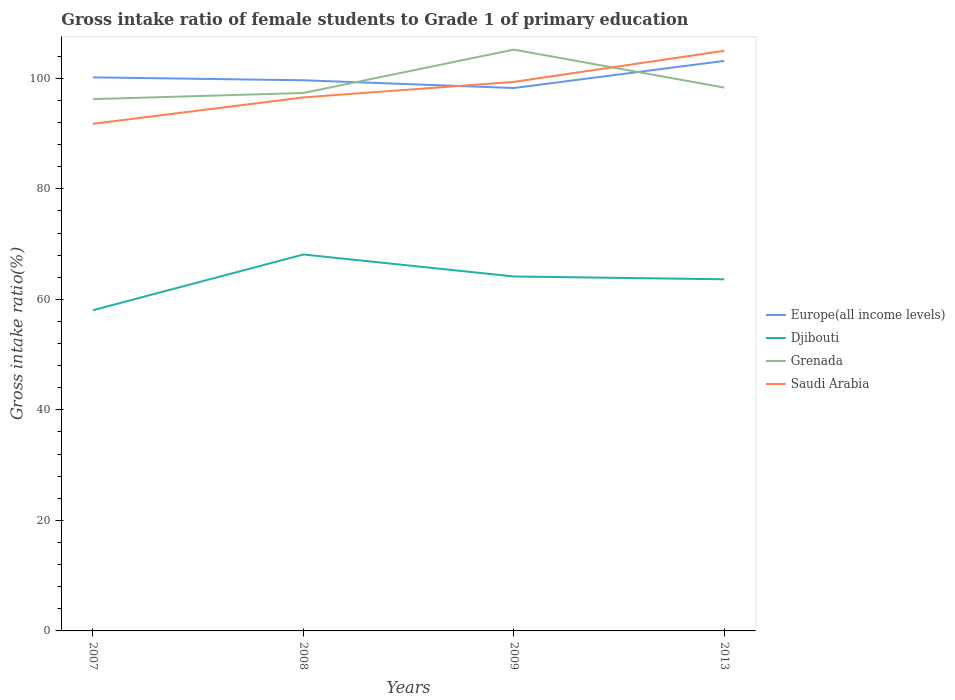How many different coloured lines are there?
Offer a very short reply. 4. Across all years, what is the maximum gross intake ratio in Saudi Arabia?
Keep it short and to the point. 91.78. In which year was the gross intake ratio in Saudi Arabia maximum?
Offer a very short reply. 2007. What is the total gross intake ratio in Grenada in the graph?
Your response must be concise. -1.11. What is the difference between the highest and the second highest gross intake ratio in Djibouti?
Your answer should be compact. 10.08. What is the difference between the highest and the lowest gross intake ratio in Europe(all income levels)?
Keep it short and to the point. 1. How many lines are there?
Ensure brevity in your answer.  4. How many years are there in the graph?
Ensure brevity in your answer.  4. What is the difference between two consecutive major ticks on the Y-axis?
Give a very brief answer. 20. Are the values on the major ticks of Y-axis written in scientific E-notation?
Offer a terse response. No. Does the graph contain any zero values?
Offer a terse response. No. How many legend labels are there?
Keep it short and to the point. 4. How are the legend labels stacked?
Make the answer very short. Vertical. What is the title of the graph?
Keep it short and to the point. Gross intake ratio of female students to Grade 1 of primary education. What is the label or title of the Y-axis?
Ensure brevity in your answer.  Gross intake ratio(%). What is the Gross intake ratio(%) of Europe(all income levels) in 2007?
Your response must be concise. 100.18. What is the Gross intake ratio(%) in Djibouti in 2007?
Provide a succinct answer. 58.04. What is the Gross intake ratio(%) of Grenada in 2007?
Offer a very short reply. 96.24. What is the Gross intake ratio(%) of Saudi Arabia in 2007?
Your answer should be very brief. 91.78. What is the Gross intake ratio(%) of Europe(all income levels) in 2008?
Your answer should be very brief. 99.66. What is the Gross intake ratio(%) in Djibouti in 2008?
Provide a succinct answer. 68.12. What is the Gross intake ratio(%) in Grenada in 2008?
Your answer should be compact. 97.35. What is the Gross intake ratio(%) in Saudi Arabia in 2008?
Offer a terse response. 96.55. What is the Gross intake ratio(%) of Europe(all income levels) in 2009?
Offer a terse response. 98.25. What is the Gross intake ratio(%) in Djibouti in 2009?
Make the answer very short. 64.15. What is the Gross intake ratio(%) of Grenada in 2009?
Provide a short and direct response. 105.2. What is the Gross intake ratio(%) in Saudi Arabia in 2009?
Your answer should be compact. 99.36. What is the Gross intake ratio(%) in Europe(all income levels) in 2013?
Offer a terse response. 103.16. What is the Gross intake ratio(%) of Djibouti in 2013?
Offer a very short reply. 63.64. What is the Gross intake ratio(%) in Grenada in 2013?
Provide a short and direct response. 98.33. What is the Gross intake ratio(%) of Saudi Arabia in 2013?
Give a very brief answer. 104.99. Across all years, what is the maximum Gross intake ratio(%) in Europe(all income levels)?
Keep it short and to the point. 103.16. Across all years, what is the maximum Gross intake ratio(%) in Djibouti?
Your answer should be compact. 68.12. Across all years, what is the maximum Gross intake ratio(%) in Grenada?
Your response must be concise. 105.2. Across all years, what is the maximum Gross intake ratio(%) of Saudi Arabia?
Keep it short and to the point. 104.99. Across all years, what is the minimum Gross intake ratio(%) of Europe(all income levels)?
Offer a terse response. 98.25. Across all years, what is the minimum Gross intake ratio(%) of Djibouti?
Provide a succinct answer. 58.04. Across all years, what is the minimum Gross intake ratio(%) of Grenada?
Give a very brief answer. 96.24. Across all years, what is the minimum Gross intake ratio(%) in Saudi Arabia?
Provide a short and direct response. 91.78. What is the total Gross intake ratio(%) in Europe(all income levels) in the graph?
Your answer should be very brief. 401.25. What is the total Gross intake ratio(%) of Djibouti in the graph?
Your answer should be compact. 253.95. What is the total Gross intake ratio(%) of Grenada in the graph?
Provide a short and direct response. 397.13. What is the total Gross intake ratio(%) in Saudi Arabia in the graph?
Ensure brevity in your answer.  392.68. What is the difference between the Gross intake ratio(%) in Europe(all income levels) in 2007 and that in 2008?
Keep it short and to the point. 0.52. What is the difference between the Gross intake ratio(%) in Djibouti in 2007 and that in 2008?
Make the answer very short. -10.08. What is the difference between the Gross intake ratio(%) of Grenada in 2007 and that in 2008?
Offer a terse response. -1.11. What is the difference between the Gross intake ratio(%) of Saudi Arabia in 2007 and that in 2008?
Ensure brevity in your answer.  -4.77. What is the difference between the Gross intake ratio(%) of Europe(all income levels) in 2007 and that in 2009?
Make the answer very short. 1.93. What is the difference between the Gross intake ratio(%) of Djibouti in 2007 and that in 2009?
Offer a terse response. -6.1. What is the difference between the Gross intake ratio(%) of Grenada in 2007 and that in 2009?
Your response must be concise. -8.96. What is the difference between the Gross intake ratio(%) of Saudi Arabia in 2007 and that in 2009?
Offer a terse response. -7.58. What is the difference between the Gross intake ratio(%) of Europe(all income levels) in 2007 and that in 2013?
Make the answer very short. -2.98. What is the difference between the Gross intake ratio(%) of Djibouti in 2007 and that in 2013?
Offer a very short reply. -5.59. What is the difference between the Gross intake ratio(%) of Grenada in 2007 and that in 2013?
Your answer should be very brief. -2.09. What is the difference between the Gross intake ratio(%) of Saudi Arabia in 2007 and that in 2013?
Your answer should be compact. -13.21. What is the difference between the Gross intake ratio(%) of Europe(all income levels) in 2008 and that in 2009?
Ensure brevity in your answer.  1.4. What is the difference between the Gross intake ratio(%) of Djibouti in 2008 and that in 2009?
Provide a succinct answer. 3.98. What is the difference between the Gross intake ratio(%) of Grenada in 2008 and that in 2009?
Keep it short and to the point. -7.85. What is the difference between the Gross intake ratio(%) in Saudi Arabia in 2008 and that in 2009?
Your answer should be very brief. -2.81. What is the difference between the Gross intake ratio(%) in Europe(all income levels) in 2008 and that in 2013?
Give a very brief answer. -3.5. What is the difference between the Gross intake ratio(%) in Djibouti in 2008 and that in 2013?
Provide a succinct answer. 4.49. What is the difference between the Gross intake ratio(%) in Grenada in 2008 and that in 2013?
Provide a short and direct response. -0.98. What is the difference between the Gross intake ratio(%) of Saudi Arabia in 2008 and that in 2013?
Give a very brief answer. -8.44. What is the difference between the Gross intake ratio(%) in Europe(all income levels) in 2009 and that in 2013?
Keep it short and to the point. -4.9. What is the difference between the Gross intake ratio(%) in Djibouti in 2009 and that in 2013?
Provide a succinct answer. 0.51. What is the difference between the Gross intake ratio(%) in Grenada in 2009 and that in 2013?
Your answer should be compact. 6.87. What is the difference between the Gross intake ratio(%) in Saudi Arabia in 2009 and that in 2013?
Give a very brief answer. -5.62. What is the difference between the Gross intake ratio(%) in Europe(all income levels) in 2007 and the Gross intake ratio(%) in Djibouti in 2008?
Provide a short and direct response. 32.06. What is the difference between the Gross intake ratio(%) of Europe(all income levels) in 2007 and the Gross intake ratio(%) of Grenada in 2008?
Your answer should be compact. 2.83. What is the difference between the Gross intake ratio(%) of Europe(all income levels) in 2007 and the Gross intake ratio(%) of Saudi Arabia in 2008?
Make the answer very short. 3.63. What is the difference between the Gross intake ratio(%) in Djibouti in 2007 and the Gross intake ratio(%) in Grenada in 2008?
Your answer should be compact. -39.31. What is the difference between the Gross intake ratio(%) of Djibouti in 2007 and the Gross intake ratio(%) of Saudi Arabia in 2008?
Your response must be concise. -38.51. What is the difference between the Gross intake ratio(%) of Grenada in 2007 and the Gross intake ratio(%) of Saudi Arabia in 2008?
Offer a very short reply. -0.31. What is the difference between the Gross intake ratio(%) in Europe(all income levels) in 2007 and the Gross intake ratio(%) in Djibouti in 2009?
Keep it short and to the point. 36.03. What is the difference between the Gross intake ratio(%) in Europe(all income levels) in 2007 and the Gross intake ratio(%) in Grenada in 2009?
Ensure brevity in your answer.  -5.02. What is the difference between the Gross intake ratio(%) of Europe(all income levels) in 2007 and the Gross intake ratio(%) of Saudi Arabia in 2009?
Keep it short and to the point. 0.82. What is the difference between the Gross intake ratio(%) in Djibouti in 2007 and the Gross intake ratio(%) in Grenada in 2009?
Keep it short and to the point. -47.16. What is the difference between the Gross intake ratio(%) of Djibouti in 2007 and the Gross intake ratio(%) of Saudi Arabia in 2009?
Provide a short and direct response. -41.32. What is the difference between the Gross intake ratio(%) in Grenada in 2007 and the Gross intake ratio(%) in Saudi Arabia in 2009?
Your response must be concise. -3.12. What is the difference between the Gross intake ratio(%) in Europe(all income levels) in 2007 and the Gross intake ratio(%) in Djibouti in 2013?
Provide a succinct answer. 36.54. What is the difference between the Gross intake ratio(%) of Europe(all income levels) in 2007 and the Gross intake ratio(%) of Grenada in 2013?
Your response must be concise. 1.85. What is the difference between the Gross intake ratio(%) of Europe(all income levels) in 2007 and the Gross intake ratio(%) of Saudi Arabia in 2013?
Your answer should be very brief. -4.81. What is the difference between the Gross intake ratio(%) in Djibouti in 2007 and the Gross intake ratio(%) in Grenada in 2013?
Your answer should be compact. -40.29. What is the difference between the Gross intake ratio(%) of Djibouti in 2007 and the Gross intake ratio(%) of Saudi Arabia in 2013?
Offer a terse response. -46.94. What is the difference between the Gross intake ratio(%) in Grenada in 2007 and the Gross intake ratio(%) in Saudi Arabia in 2013?
Your response must be concise. -8.75. What is the difference between the Gross intake ratio(%) of Europe(all income levels) in 2008 and the Gross intake ratio(%) of Djibouti in 2009?
Your response must be concise. 35.51. What is the difference between the Gross intake ratio(%) of Europe(all income levels) in 2008 and the Gross intake ratio(%) of Grenada in 2009?
Offer a terse response. -5.55. What is the difference between the Gross intake ratio(%) of Europe(all income levels) in 2008 and the Gross intake ratio(%) of Saudi Arabia in 2009?
Make the answer very short. 0.29. What is the difference between the Gross intake ratio(%) in Djibouti in 2008 and the Gross intake ratio(%) in Grenada in 2009?
Give a very brief answer. -37.08. What is the difference between the Gross intake ratio(%) in Djibouti in 2008 and the Gross intake ratio(%) in Saudi Arabia in 2009?
Your response must be concise. -31.24. What is the difference between the Gross intake ratio(%) of Grenada in 2008 and the Gross intake ratio(%) of Saudi Arabia in 2009?
Offer a very short reply. -2.01. What is the difference between the Gross intake ratio(%) of Europe(all income levels) in 2008 and the Gross intake ratio(%) of Djibouti in 2013?
Give a very brief answer. 36.02. What is the difference between the Gross intake ratio(%) of Europe(all income levels) in 2008 and the Gross intake ratio(%) of Grenada in 2013?
Your response must be concise. 1.32. What is the difference between the Gross intake ratio(%) of Europe(all income levels) in 2008 and the Gross intake ratio(%) of Saudi Arabia in 2013?
Keep it short and to the point. -5.33. What is the difference between the Gross intake ratio(%) in Djibouti in 2008 and the Gross intake ratio(%) in Grenada in 2013?
Provide a short and direct response. -30.21. What is the difference between the Gross intake ratio(%) of Djibouti in 2008 and the Gross intake ratio(%) of Saudi Arabia in 2013?
Ensure brevity in your answer.  -36.86. What is the difference between the Gross intake ratio(%) of Grenada in 2008 and the Gross intake ratio(%) of Saudi Arabia in 2013?
Your answer should be very brief. -7.63. What is the difference between the Gross intake ratio(%) in Europe(all income levels) in 2009 and the Gross intake ratio(%) in Djibouti in 2013?
Give a very brief answer. 34.62. What is the difference between the Gross intake ratio(%) of Europe(all income levels) in 2009 and the Gross intake ratio(%) of Grenada in 2013?
Ensure brevity in your answer.  -0.08. What is the difference between the Gross intake ratio(%) in Europe(all income levels) in 2009 and the Gross intake ratio(%) in Saudi Arabia in 2013?
Ensure brevity in your answer.  -6.73. What is the difference between the Gross intake ratio(%) of Djibouti in 2009 and the Gross intake ratio(%) of Grenada in 2013?
Provide a short and direct response. -34.18. What is the difference between the Gross intake ratio(%) of Djibouti in 2009 and the Gross intake ratio(%) of Saudi Arabia in 2013?
Your response must be concise. -40.84. What is the difference between the Gross intake ratio(%) in Grenada in 2009 and the Gross intake ratio(%) in Saudi Arabia in 2013?
Ensure brevity in your answer.  0.22. What is the average Gross intake ratio(%) in Europe(all income levels) per year?
Make the answer very short. 100.31. What is the average Gross intake ratio(%) of Djibouti per year?
Keep it short and to the point. 63.49. What is the average Gross intake ratio(%) of Grenada per year?
Your answer should be very brief. 99.28. What is the average Gross intake ratio(%) of Saudi Arabia per year?
Give a very brief answer. 98.17. In the year 2007, what is the difference between the Gross intake ratio(%) of Europe(all income levels) and Gross intake ratio(%) of Djibouti?
Give a very brief answer. 42.14. In the year 2007, what is the difference between the Gross intake ratio(%) in Europe(all income levels) and Gross intake ratio(%) in Grenada?
Ensure brevity in your answer.  3.94. In the year 2007, what is the difference between the Gross intake ratio(%) of Europe(all income levels) and Gross intake ratio(%) of Saudi Arabia?
Ensure brevity in your answer.  8.4. In the year 2007, what is the difference between the Gross intake ratio(%) in Djibouti and Gross intake ratio(%) in Grenada?
Provide a succinct answer. -38.2. In the year 2007, what is the difference between the Gross intake ratio(%) in Djibouti and Gross intake ratio(%) in Saudi Arabia?
Make the answer very short. -33.74. In the year 2007, what is the difference between the Gross intake ratio(%) in Grenada and Gross intake ratio(%) in Saudi Arabia?
Make the answer very short. 4.46. In the year 2008, what is the difference between the Gross intake ratio(%) of Europe(all income levels) and Gross intake ratio(%) of Djibouti?
Offer a terse response. 31.53. In the year 2008, what is the difference between the Gross intake ratio(%) in Europe(all income levels) and Gross intake ratio(%) in Grenada?
Keep it short and to the point. 2.3. In the year 2008, what is the difference between the Gross intake ratio(%) in Europe(all income levels) and Gross intake ratio(%) in Saudi Arabia?
Make the answer very short. 3.1. In the year 2008, what is the difference between the Gross intake ratio(%) in Djibouti and Gross intake ratio(%) in Grenada?
Offer a terse response. -29.23. In the year 2008, what is the difference between the Gross intake ratio(%) in Djibouti and Gross intake ratio(%) in Saudi Arabia?
Give a very brief answer. -28.43. In the year 2008, what is the difference between the Gross intake ratio(%) in Grenada and Gross intake ratio(%) in Saudi Arabia?
Provide a short and direct response. 0.8. In the year 2009, what is the difference between the Gross intake ratio(%) in Europe(all income levels) and Gross intake ratio(%) in Djibouti?
Ensure brevity in your answer.  34.11. In the year 2009, what is the difference between the Gross intake ratio(%) of Europe(all income levels) and Gross intake ratio(%) of Grenada?
Your answer should be compact. -6.95. In the year 2009, what is the difference between the Gross intake ratio(%) in Europe(all income levels) and Gross intake ratio(%) in Saudi Arabia?
Your answer should be compact. -1.11. In the year 2009, what is the difference between the Gross intake ratio(%) of Djibouti and Gross intake ratio(%) of Grenada?
Keep it short and to the point. -41.06. In the year 2009, what is the difference between the Gross intake ratio(%) in Djibouti and Gross intake ratio(%) in Saudi Arabia?
Offer a very short reply. -35.21. In the year 2009, what is the difference between the Gross intake ratio(%) of Grenada and Gross intake ratio(%) of Saudi Arabia?
Your response must be concise. 5.84. In the year 2013, what is the difference between the Gross intake ratio(%) in Europe(all income levels) and Gross intake ratio(%) in Djibouti?
Provide a succinct answer. 39.52. In the year 2013, what is the difference between the Gross intake ratio(%) in Europe(all income levels) and Gross intake ratio(%) in Grenada?
Ensure brevity in your answer.  4.83. In the year 2013, what is the difference between the Gross intake ratio(%) of Europe(all income levels) and Gross intake ratio(%) of Saudi Arabia?
Give a very brief answer. -1.83. In the year 2013, what is the difference between the Gross intake ratio(%) in Djibouti and Gross intake ratio(%) in Grenada?
Your response must be concise. -34.7. In the year 2013, what is the difference between the Gross intake ratio(%) in Djibouti and Gross intake ratio(%) in Saudi Arabia?
Offer a very short reply. -41.35. In the year 2013, what is the difference between the Gross intake ratio(%) in Grenada and Gross intake ratio(%) in Saudi Arabia?
Give a very brief answer. -6.66. What is the ratio of the Gross intake ratio(%) in Europe(all income levels) in 2007 to that in 2008?
Make the answer very short. 1.01. What is the ratio of the Gross intake ratio(%) in Djibouti in 2007 to that in 2008?
Make the answer very short. 0.85. What is the ratio of the Gross intake ratio(%) in Saudi Arabia in 2007 to that in 2008?
Offer a very short reply. 0.95. What is the ratio of the Gross intake ratio(%) of Europe(all income levels) in 2007 to that in 2009?
Offer a very short reply. 1.02. What is the ratio of the Gross intake ratio(%) of Djibouti in 2007 to that in 2009?
Offer a very short reply. 0.9. What is the ratio of the Gross intake ratio(%) of Grenada in 2007 to that in 2009?
Offer a terse response. 0.91. What is the ratio of the Gross intake ratio(%) in Saudi Arabia in 2007 to that in 2009?
Offer a very short reply. 0.92. What is the ratio of the Gross intake ratio(%) of Europe(all income levels) in 2007 to that in 2013?
Provide a succinct answer. 0.97. What is the ratio of the Gross intake ratio(%) of Djibouti in 2007 to that in 2013?
Offer a very short reply. 0.91. What is the ratio of the Gross intake ratio(%) in Grenada in 2007 to that in 2013?
Give a very brief answer. 0.98. What is the ratio of the Gross intake ratio(%) of Saudi Arabia in 2007 to that in 2013?
Ensure brevity in your answer.  0.87. What is the ratio of the Gross intake ratio(%) in Europe(all income levels) in 2008 to that in 2009?
Your answer should be compact. 1.01. What is the ratio of the Gross intake ratio(%) of Djibouti in 2008 to that in 2009?
Provide a short and direct response. 1.06. What is the ratio of the Gross intake ratio(%) in Grenada in 2008 to that in 2009?
Offer a terse response. 0.93. What is the ratio of the Gross intake ratio(%) of Saudi Arabia in 2008 to that in 2009?
Your answer should be very brief. 0.97. What is the ratio of the Gross intake ratio(%) in Europe(all income levels) in 2008 to that in 2013?
Your answer should be compact. 0.97. What is the ratio of the Gross intake ratio(%) of Djibouti in 2008 to that in 2013?
Provide a succinct answer. 1.07. What is the ratio of the Gross intake ratio(%) of Saudi Arabia in 2008 to that in 2013?
Offer a very short reply. 0.92. What is the ratio of the Gross intake ratio(%) in Europe(all income levels) in 2009 to that in 2013?
Make the answer very short. 0.95. What is the ratio of the Gross intake ratio(%) in Grenada in 2009 to that in 2013?
Give a very brief answer. 1.07. What is the ratio of the Gross intake ratio(%) in Saudi Arabia in 2009 to that in 2013?
Keep it short and to the point. 0.95. What is the difference between the highest and the second highest Gross intake ratio(%) of Europe(all income levels)?
Your answer should be very brief. 2.98. What is the difference between the highest and the second highest Gross intake ratio(%) of Djibouti?
Your answer should be very brief. 3.98. What is the difference between the highest and the second highest Gross intake ratio(%) of Grenada?
Your answer should be compact. 6.87. What is the difference between the highest and the second highest Gross intake ratio(%) in Saudi Arabia?
Your answer should be compact. 5.62. What is the difference between the highest and the lowest Gross intake ratio(%) in Europe(all income levels)?
Your answer should be very brief. 4.9. What is the difference between the highest and the lowest Gross intake ratio(%) in Djibouti?
Your answer should be compact. 10.08. What is the difference between the highest and the lowest Gross intake ratio(%) of Grenada?
Provide a succinct answer. 8.96. What is the difference between the highest and the lowest Gross intake ratio(%) of Saudi Arabia?
Provide a short and direct response. 13.21. 